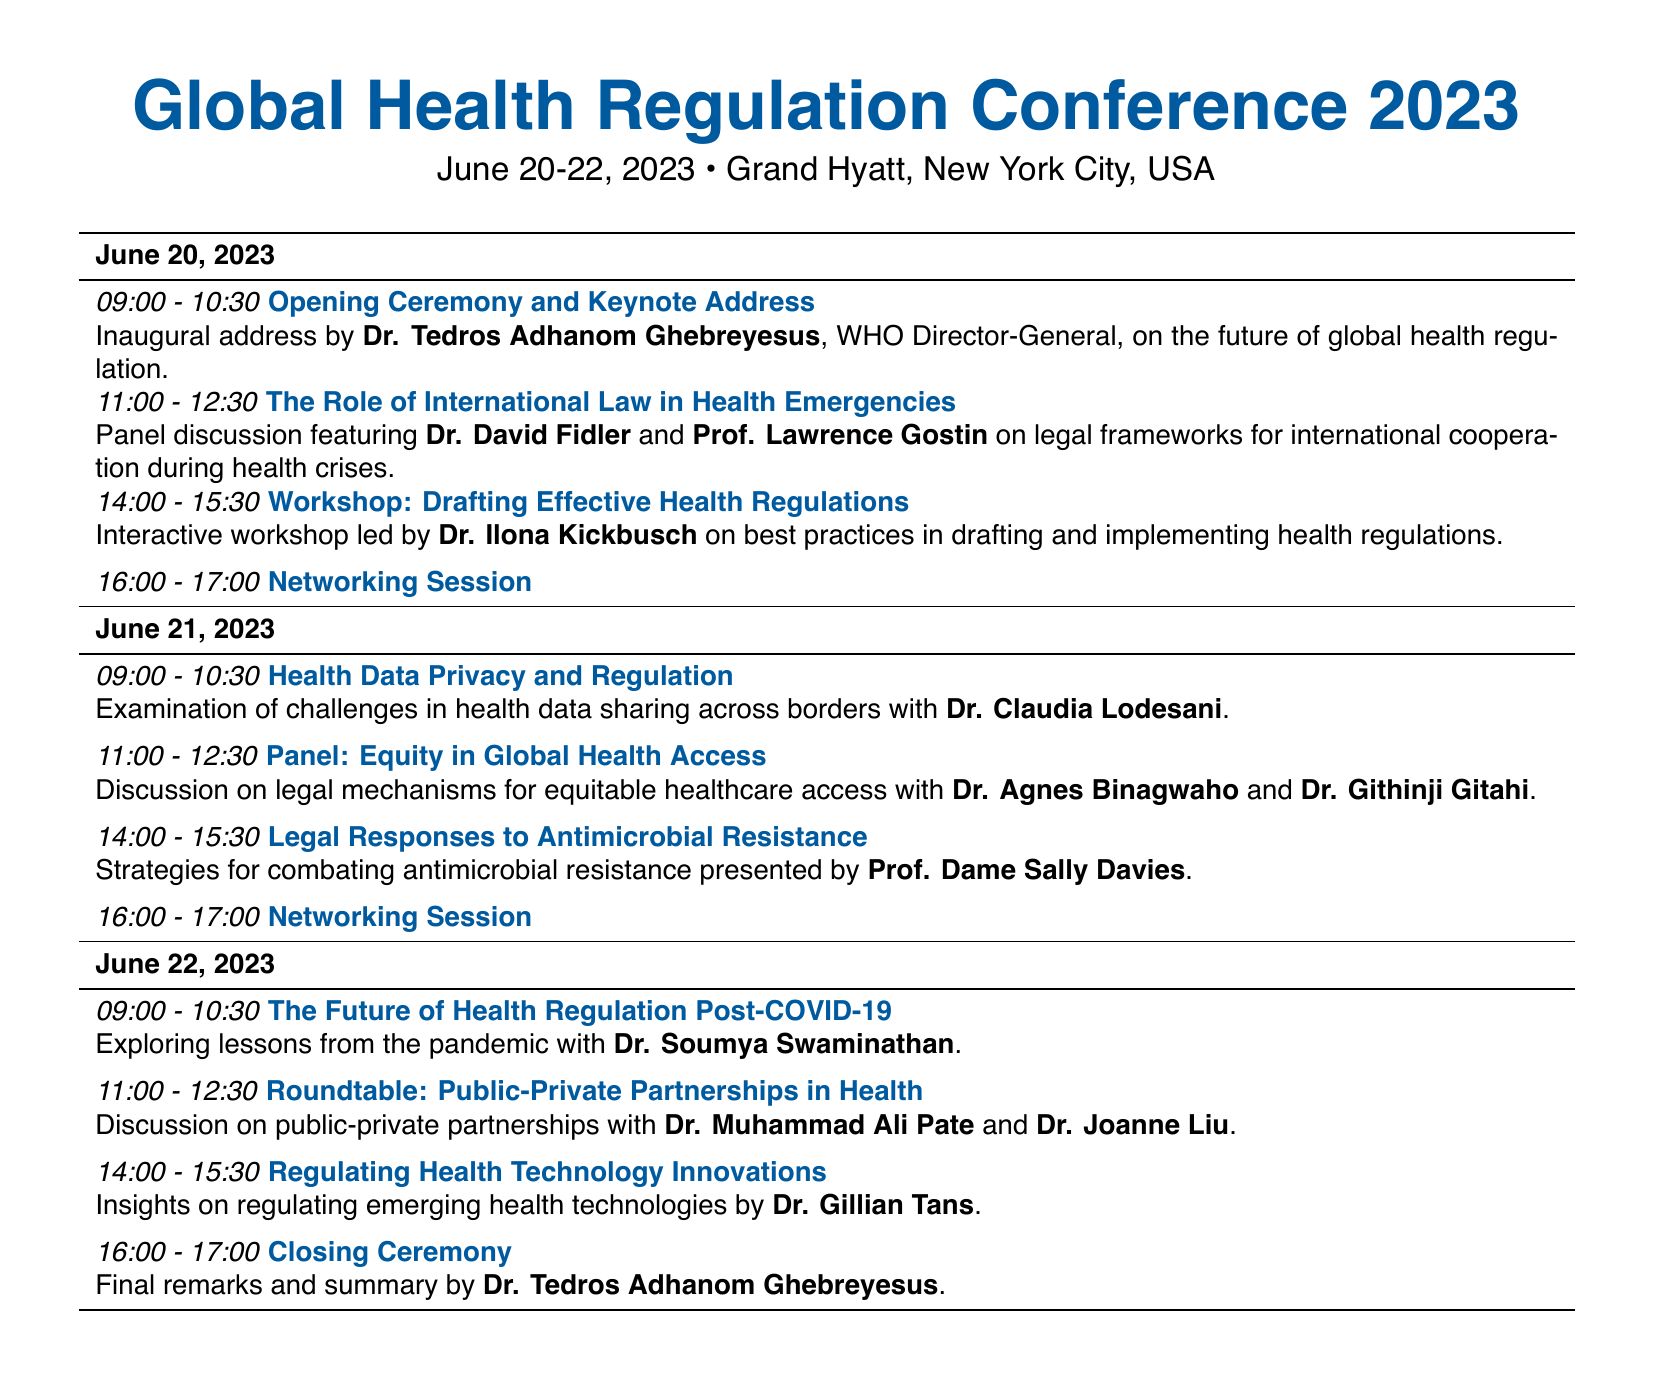What is the date of the Global Health Regulation Conference? The date of the conference is explicitly stated at the beginning of the document, which is June 20-22, 2023.
Answer: June 20-22, 2023 Who is the speaker for the Opening Ceremony? The speaker for the Opening Ceremony is mentioned in the session description for the inaugural address.
Answer: Dr. Tedros Adhanom Ghebreyesus What session is scheduled at 09:00 on June 21? The session at this time is indicated in the schedule for that date.
Answer: Health Data Privacy and Regulation How many networking sessions are there in total? The document lists two networking sessions on each of the three days of the conference, leading to a total count.
Answer: 6 What is the focus of the session led by Dr. Ilona Kickbusch? The workshop description specifies that it focuses on best practices in drafting and implementing health regulations.
Answer: Drafting Effective Health Regulations Which session discusses legal responses to antimicrobial resistance? The document contains a specific session dedicated to this topic and lists the speaker accordingly.
Answer: Legal Responses to Antimicrobial Resistance Who are the two speakers in the roundtable discussion on public-private partnerships? The session details provide the names of the speakers involved in this discussion.
Answer: Dr. Muhammad Ali Pate and Dr. Joanne Liu What time does the Closing Ceremony start? The session schedule outlines the specific time allocated for the Closing Ceremony on the final day.
Answer: 16:00 - 17:00 